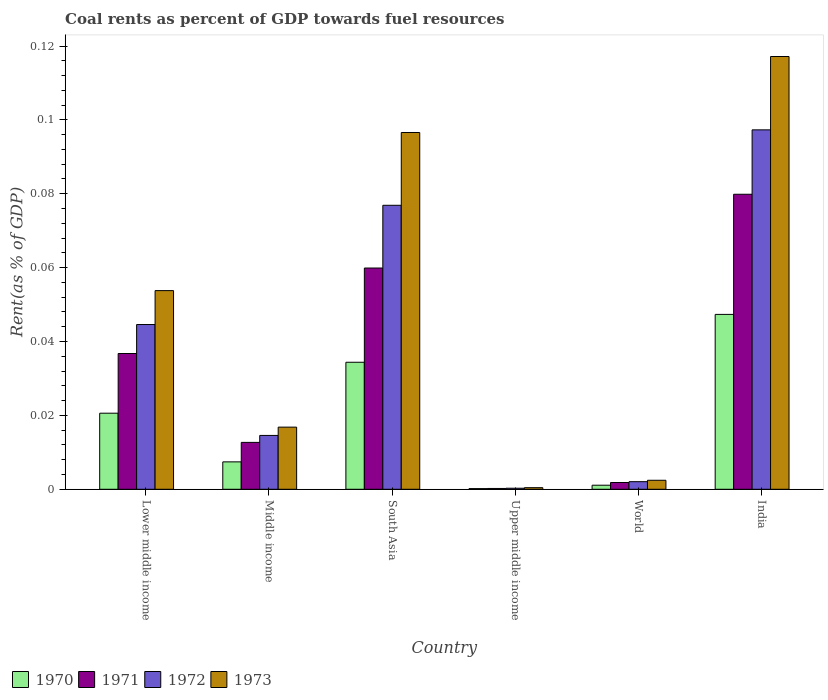Are the number of bars on each tick of the X-axis equal?
Your answer should be very brief. Yes. What is the label of the 6th group of bars from the left?
Offer a very short reply. India. What is the coal rent in 1973 in Upper middle income?
Your response must be concise. 0. Across all countries, what is the maximum coal rent in 1971?
Your answer should be very brief. 0.08. Across all countries, what is the minimum coal rent in 1970?
Offer a terse response. 0. In which country was the coal rent in 1970 minimum?
Provide a succinct answer. Upper middle income. What is the total coal rent in 1971 in the graph?
Offer a very short reply. 0.19. What is the difference between the coal rent in 1973 in Middle income and that in World?
Make the answer very short. 0.01. What is the difference between the coal rent in 1971 in Lower middle income and the coal rent in 1973 in India?
Offer a very short reply. -0.08. What is the average coal rent in 1970 per country?
Provide a succinct answer. 0.02. What is the difference between the coal rent of/in 1971 and coal rent of/in 1972 in Upper middle income?
Your answer should be very brief. -6.559434765832401e-5. What is the ratio of the coal rent in 1970 in Upper middle income to that in World?
Offer a very short reply. 0.17. What is the difference between the highest and the second highest coal rent in 1971?
Your answer should be very brief. 0.04. What is the difference between the highest and the lowest coal rent in 1973?
Keep it short and to the point. 0.12. In how many countries, is the coal rent in 1973 greater than the average coal rent in 1973 taken over all countries?
Offer a terse response. 3. Is the sum of the coal rent in 1971 in Middle income and World greater than the maximum coal rent in 1970 across all countries?
Offer a very short reply. No. What does the 4th bar from the left in Upper middle income represents?
Make the answer very short. 1973. How many bars are there?
Keep it short and to the point. 24. What is the difference between two consecutive major ticks on the Y-axis?
Give a very brief answer. 0.02. Does the graph contain grids?
Give a very brief answer. No. Where does the legend appear in the graph?
Make the answer very short. Bottom left. How many legend labels are there?
Your answer should be compact. 4. What is the title of the graph?
Offer a terse response. Coal rents as percent of GDP towards fuel resources. What is the label or title of the X-axis?
Your response must be concise. Country. What is the label or title of the Y-axis?
Keep it short and to the point. Rent(as % of GDP). What is the Rent(as % of GDP) in 1970 in Lower middle income?
Make the answer very short. 0.02. What is the Rent(as % of GDP) of 1971 in Lower middle income?
Make the answer very short. 0.04. What is the Rent(as % of GDP) of 1972 in Lower middle income?
Offer a very short reply. 0.04. What is the Rent(as % of GDP) of 1973 in Lower middle income?
Provide a short and direct response. 0.05. What is the Rent(as % of GDP) in 1970 in Middle income?
Provide a succinct answer. 0.01. What is the Rent(as % of GDP) of 1971 in Middle income?
Your answer should be compact. 0.01. What is the Rent(as % of GDP) of 1972 in Middle income?
Offer a very short reply. 0.01. What is the Rent(as % of GDP) of 1973 in Middle income?
Keep it short and to the point. 0.02. What is the Rent(as % of GDP) of 1970 in South Asia?
Provide a succinct answer. 0.03. What is the Rent(as % of GDP) in 1971 in South Asia?
Offer a very short reply. 0.06. What is the Rent(as % of GDP) of 1972 in South Asia?
Keep it short and to the point. 0.08. What is the Rent(as % of GDP) of 1973 in South Asia?
Your response must be concise. 0.1. What is the Rent(as % of GDP) in 1970 in Upper middle income?
Your response must be concise. 0. What is the Rent(as % of GDP) of 1971 in Upper middle income?
Give a very brief answer. 0. What is the Rent(as % of GDP) of 1972 in Upper middle income?
Give a very brief answer. 0. What is the Rent(as % of GDP) in 1973 in Upper middle income?
Your response must be concise. 0. What is the Rent(as % of GDP) of 1970 in World?
Offer a very short reply. 0. What is the Rent(as % of GDP) in 1971 in World?
Offer a terse response. 0. What is the Rent(as % of GDP) in 1972 in World?
Offer a terse response. 0. What is the Rent(as % of GDP) in 1973 in World?
Provide a short and direct response. 0. What is the Rent(as % of GDP) of 1970 in India?
Keep it short and to the point. 0.05. What is the Rent(as % of GDP) of 1971 in India?
Offer a terse response. 0.08. What is the Rent(as % of GDP) of 1972 in India?
Offer a very short reply. 0.1. What is the Rent(as % of GDP) of 1973 in India?
Keep it short and to the point. 0.12. Across all countries, what is the maximum Rent(as % of GDP) of 1970?
Your answer should be compact. 0.05. Across all countries, what is the maximum Rent(as % of GDP) in 1971?
Offer a very short reply. 0.08. Across all countries, what is the maximum Rent(as % of GDP) in 1972?
Provide a short and direct response. 0.1. Across all countries, what is the maximum Rent(as % of GDP) in 1973?
Make the answer very short. 0.12. Across all countries, what is the minimum Rent(as % of GDP) of 1970?
Your response must be concise. 0. Across all countries, what is the minimum Rent(as % of GDP) of 1971?
Your answer should be very brief. 0. Across all countries, what is the minimum Rent(as % of GDP) in 1972?
Your answer should be compact. 0. Across all countries, what is the minimum Rent(as % of GDP) of 1973?
Offer a very short reply. 0. What is the total Rent(as % of GDP) of 1970 in the graph?
Ensure brevity in your answer.  0.11. What is the total Rent(as % of GDP) of 1971 in the graph?
Provide a succinct answer. 0.19. What is the total Rent(as % of GDP) in 1972 in the graph?
Ensure brevity in your answer.  0.24. What is the total Rent(as % of GDP) of 1973 in the graph?
Offer a very short reply. 0.29. What is the difference between the Rent(as % of GDP) in 1970 in Lower middle income and that in Middle income?
Your answer should be very brief. 0.01. What is the difference between the Rent(as % of GDP) of 1971 in Lower middle income and that in Middle income?
Your answer should be compact. 0.02. What is the difference between the Rent(as % of GDP) of 1973 in Lower middle income and that in Middle income?
Offer a very short reply. 0.04. What is the difference between the Rent(as % of GDP) in 1970 in Lower middle income and that in South Asia?
Offer a very short reply. -0.01. What is the difference between the Rent(as % of GDP) of 1971 in Lower middle income and that in South Asia?
Your answer should be very brief. -0.02. What is the difference between the Rent(as % of GDP) in 1972 in Lower middle income and that in South Asia?
Your answer should be compact. -0.03. What is the difference between the Rent(as % of GDP) of 1973 in Lower middle income and that in South Asia?
Provide a succinct answer. -0.04. What is the difference between the Rent(as % of GDP) of 1970 in Lower middle income and that in Upper middle income?
Make the answer very short. 0.02. What is the difference between the Rent(as % of GDP) in 1971 in Lower middle income and that in Upper middle income?
Make the answer very short. 0.04. What is the difference between the Rent(as % of GDP) in 1972 in Lower middle income and that in Upper middle income?
Keep it short and to the point. 0.04. What is the difference between the Rent(as % of GDP) of 1973 in Lower middle income and that in Upper middle income?
Make the answer very short. 0.05. What is the difference between the Rent(as % of GDP) in 1970 in Lower middle income and that in World?
Make the answer very short. 0.02. What is the difference between the Rent(as % of GDP) in 1971 in Lower middle income and that in World?
Keep it short and to the point. 0.03. What is the difference between the Rent(as % of GDP) in 1972 in Lower middle income and that in World?
Provide a succinct answer. 0.04. What is the difference between the Rent(as % of GDP) of 1973 in Lower middle income and that in World?
Your response must be concise. 0.05. What is the difference between the Rent(as % of GDP) in 1970 in Lower middle income and that in India?
Offer a terse response. -0.03. What is the difference between the Rent(as % of GDP) in 1971 in Lower middle income and that in India?
Give a very brief answer. -0.04. What is the difference between the Rent(as % of GDP) in 1972 in Lower middle income and that in India?
Give a very brief answer. -0.05. What is the difference between the Rent(as % of GDP) of 1973 in Lower middle income and that in India?
Offer a terse response. -0.06. What is the difference between the Rent(as % of GDP) in 1970 in Middle income and that in South Asia?
Provide a short and direct response. -0.03. What is the difference between the Rent(as % of GDP) of 1971 in Middle income and that in South Asia?
Offer a very short reply. -0.05. What is the difference between the Rent(as % of GDP) of 1972 in Middle income and that in South Asia?
Give a very brief answer. -0.06. What is the difference between the Rent(as % of GDP) of 1973 in Middle income and that in South Asia?
Provide a short and direct response. -0.08. What is the difference between the Rent(as % of GDP) of 1970 in Middle income and that in Upper middle income?
Your answer should be compact. 0.01. What is the difference between the Rent(as % of GDP) of 1971 in Middle income and that in Upper middle income?
Ensure brevity in your answer.  0.01. What is the difference between the Rent(as % of GDP) of 1972 in Middle income and that in Upper middle income?
Provide a short and direct response. 0.01. What is the difference between the Rent(as % of GDP) of 1973 in Middle income and that in Upper middle income?
Keep it short and to the point. 0.02. What is the difference between the Rent(as % of GDP) in 1970 in Middle income and that in World?
Provide a succinct answer. 0.01. What is the difference between the Rent(as % of GDP) in 1971 in Middle income and that in World?
Your answer should be compact. 0.01. What is the difference between the Rent(as % of GDP) in 1972 in Middle income and that in World?
Provide a short and direct response. 0.01. What is the difference between the Rent(as % of GDP) of 1973 in Middle income and that in World?
Your answer should be very brief. 0.01. What is the difference between the Rent(as % of GDP) in 1970 in Middle income and that in India?
Make the answer very short. -0.04. What is the difference between the Rent(as % of GDP) of 1971 in Middle income and that in India?
Ensure brevity in your answer.  -0.07. What is the difference between the Rent(as % of GDP) of 1972 in Middle income and that in India?
Ensure brevity in your answer.  -0.08. What is the difference between the Rent(as % of GDP) of 1973 in Middle income and that in India?
Offer a terse response. -0.1. What is the difference between the Rent(as % of GDP) of 1970 in South Asia and that in Upper middle income?
Your answer should be very brief. 0.03. What is the difference between the Rent(as % of GDP) of 1971 in South Asia and that in Upper middle income?
Make the answer very short. 0.06. What is the difference between the Rent(as % of GDP) in 1972 in South Asia and that in Upper middle income?
Give a very brief answer. 0.08. What is the difference between the Rent(as % of GDP) in 1973 in South Asia and that in Upper middle income?
Ensure brevity in your answer.  0.1. What is the difference between the Rent(as % of GDP) of 1971 in South Asia and that in World?
Your answer should be compact. 0.06. What is the difference between the Rent(as % of GDP) in 1972 in South Asia and that in World?
Ensure brevity in your answer.  0.07. What is the difference between the Rent(as % of GDP) in 1973 in South Asia and that in World?
Your response must be concise. 0.09. What is the difference between the Rent(as % of GDP) in 1970 in South Asia and that in India?
Offer a very short reply. -0.01. What is the difference between the Rent(as % of GDP) of 1971 in South Asia and that in India?
Provide a succinct answer. -0.02. What is the difference between the Rent(as % of GDP) of 1972 in South Asia and that in India?
Ensure brevity in your answer.  -0.02. What is the difference between the Rent(as % of GDP) in 1973 in South Asia and that in India?
Your response must be concise. -0.02. What is the difference between the Rent(as % of GDP) of 1970 in Upper middle income and that in World?
Ensure brevity in your answer.  -0. What is the difference between the Rent(as % of GDP) of 1971 in Upper middle income and that in World?
Your answer should be compact. -0. What is the difference between the Rent(as % of GDP) in 1972 in Upper middle income and that in World?
Provide a short and direct response. -0. What is the difference between the Rent(as % of GDP) in 1973 in Upper middle income and that in World?
Your response must be concise. -0. What is the difference between the Rent(as % of GDP) in 1970 in Upper middle income and that in India?
Offer a terse response. -0.05. What is the difference between the Rent(as % of GDP) in 1971 in Upper middle income and that in India?
Provide a short and direct response. -0.08. What is the difference between the Rent(as % of GDP) in 1972 in Upper middle income and that in India?
Provide a succinct answer. -0.1. What is the difference between the Rent(as % of GDP) of 1973 in Upper middle income and that in India?
Offer a terse response. -0.12. What is the difference between the Rent(as % of GDP) of 1970 in World and that in India?
Make the answer very short. -0.05. What is the difference between the Rent(as % of GDP) of 1971 in World and that in India?
Offer a terse response. -0.08. What is the difference between the Rent(as % of GDP) of 1972 in World and that in India?
Give a very brief answer. -0.1. What is the difference between the Rent(as % of GDP) in 1973 in World and that in India?
Your response must be concise. -0.11. What is the difference between the Rent(as % of GDP) of 1970 in Lower middle income and the Rent(as % of GDP) of 1971 in Middle income?
Offer a terse response. 0.01. What is the difference between the Rent(as % of GDP) of 1970 in Lower middle income and the Rent(as % of GDP) of 1972 in Middle income?
Provide a succinct answer. 0.01. What is the difference between the Rent(as % of GDP) of 1970 in Lower middle income and the Rent(as % of GDP) of 1973 in Middle income?
Offer a terse response. 0. What is the difference between the Rent(as % of GDP) in 1971 in Lower middle income and the Rent(as % of GDP) in 1972 in Middle income?
Make the answer very short. 0.02. What is the difference between the Rent(as % of GDP) in 1971 in Lower middle income and the Rent(as % of GDP) in 1973 in Middle income?
Make the answer very short. 0.02. What is the difference between the Rent(as % of GDP) in 1972 in Lower middle income and the Rent(as % of GDP) in 1973 in Middle income?
Offer a terse response. 0.03. What is the difference between the Rent(as % of GDP) of 1970 in Lower middle income and the Rent(as % of GDP) of 1971 in South Asia?
Your answer should be compact. -0.04. What is the difference between the Rent(as % of GDP) in 1970 in Lower middle income and the Rent(as % of GDP) in 1972 in South Asia?
Give a very brief answer. -0.06. What is the difference between the Rent(as % of GDP) in 1970 in Lower middle income and the Rent(as % of GDP) in 1973 in South Asia?
Your answer should be compact. -0.08. What is the difference between the Rent(as % of GDP) of 1971 in Lower middle income and the Rent(as % of GDP) of 1972 in South Asia?
Offer a terse response. -0.04. What is the difference between the Rent(as % of GDP) in 1971 in Lower middle income and the Rent(as % of GDP) in 1973 in South Asia?
Your answer should be very brief. -0.06. What is the difference between the Rent(as % of GDP) of 1972 in Lower middle income and the Rent(as % of GDP) of 1973 in South Asia?
Offer a very short reply. -0.05. What is the difference between the Rent(as % of GDP) of 1970 in Lower middle income and the Rent(as % of GDP) of 1971 in Upper middle income?
Make the answer very short. 0.02. What is the difference between the Rent(as % of GDP) in 1970 in Lower middle income and the Rent(as % of GDP) in 1972 in Upper middle income?
Give a very brief answer. 0.02. What is the difference between the Rent(as % of GDP) in 1970 in Lower middle income and the Rent(as % of GDP) in 1973 in Upper middle income?
Provide a succinct answer. 0.02. What is the difference between the Rent(as % of GDP) of 1971 in Lower middle income and the Rent(as % of GDP) of 1972 in Upper middle income?
Your answer should be very brief. 0.04. What is the difference between the Rent(as % of GDP) in 1971 in Lower middle income and the Rent(as % of GDP) in 1973 in Upper middle income?
Your response must be concise. 0.04. What is the difference between the Rent(as % of GDP) in 1972 in Lower middle income and the Rent(as % of GDP) in 1973 in Upper middle income?
Provide a succinct answer. 0.04. What is the difference between the Rent(as % of GDP) in 1970 in Lower middle income and the Rent(as % of GDP) in 1971 in World?
Provide a succinct answer. 0.02. What is the difference between the Rent(as % of GDP) of 1970 in Lower middle income and the Rent(as % of GDP) of 1972 in World?
Keep it short and to the point. 0.02. What is the difference between the Rent(as % of GDP) in 1970 in Lower middle income and the Rent(as % of GDP) in 1973 in World?
Your answer should be compact. 0.02. What is the difference between the Rent(as % of GDP) of 1971 in Lower middle income and the Rent(as % of GDP) of 1972 in World?
Ensure brevity in your answer.  0.03. What is the difference between the Rent(as % of GDP) of 1971 in Lower middle income and the Rent(as % of GDP) of 1973 in World?
Make the answer very short. 0.03. What is the difference between the Rent(as % of GDP) of 1972 in Lower middle income and the Rent(as % of GDP) of 1973 in World?
Provide a short and direct response. 0.04. What is the difference between the Rent(as % of GDP) in 1970 in Lower middle income and the Rent(as % of GDP) in 1971 in India?
Give a very brief answer. -0.06. What is the difference between the Rent(as % of GDP) in 1970 in Lower middle income and the Rent(as % of GDP) in 1972 in India?
Give a very brief answer. -0.08. What is the difference between the Rent(as % of GDP) of 1970 in Lower middle income and the Rent(as % of GDP) of 1973 in India?
Your answer should be compact. -0.1. What is the difference between the Rent(as % of GDP) in 1971 in Lower middle income and the Rent(as % of GDP) in 1972 in India?
Ensure brevity in your answer.  -0.06. What is the difference between the Rent(as % of GDP) in 1971 in Lower middle income and the Rent(as % of GDP) in 1973 in India?
Make the answer very short. -0.08. What is the difference between the Rent(as % of GDP) in 1972 in Lower middle income and the Rent(as % of GDP) in 1973 in India?
Your answer should be very brief. -0.07. What is the difference between the Rent(as % of GDP) in 1970 in Middle income and the Rent(as % of GDP) in 1971 in South Asia?
Provide a short and direct response. -0.05. What is the difference between the Rent(as % of GDP) in 1970 in Middle income and the Rent(as % of GDP) in 1972 in South Asia?
Your answer should be compact. -0.07. What is the difference between the Rent(as % of GDP) of 1970 in Middle income and the Rent(as % of GDP) of 1973 in South Asia?
Provide a succinct answer. -0.09. What is the difference between the Rent(as % of GDP) of 1971 in Middle income and the Rent(as % of GDP) of 1972 in South Asia?
Your answer should be very brief. -0.06. What is the difference between the Rent(as % of GDP) of 1971 in Middle income and the Rent(as % of GDP) of 1973 in South Asia?
Your answer should be very brief. -0.08. What is the difference between the Rent(as % of GDP) in 1972 in Middle income and the Rent(as % of GDP) in 1973 in South Asia?
Provide a short and direct response. -0.08. What is the difference between the Rent(as % of GDP) of 1970 in Middle income and the Rent(as % of GDP) of 1971 in Upper middle income?
Keep it short and to the point. 0.01. What is the difference between the Rent(as % of GDP) in 1970 in Middle income and the Rent(as % of GDP) in 1972 in Upper middle income?
Offer a terse response. 0.01. What is the difference between the Rent(as % of GDP) of 1970 in Middle income and the Rent(as % of GDP) of 1973 in Upper middle income?
Ensure brevity in your answer.  0.01. What is the difference between the Rent(as % of GDP) in 1971 in Middle income and the Rent(as % of GDP) in 1972 in Upper middle income?
Provide a short and direct response. 0.01. What is the difference between the Rent(as % of GDP) in 1971 in Middle income and the Rent(as % of GDP) in 1973 in Upper middle income?
Ensure brevity in your answer.  0.01. What is the difference between the Rent(as % of GDP) of 1972 in Middle income and the Rent(as % of GDP) of 1973 in Upper middle income?
Ensure brevity in your answer.  0.01. What is the difference between the Rent(as % of GDP) of 1970 in Middle income and the Rent(as % of GDP) of 1971 in World?
Your response must be concise. 0.01. What is the difference between the Rent(as % of GDP) of 1970 in Middle income and the Rent(as % of GDP) of 1972 in World?
Your answer should be very brief. 0.01. What is the difference between the Rent(as % of GDP) of 1970 in Middle income and the Rent(as % of GDP) of 1973 in World?
Offer a terse response. 0.01. What is the difference between the Rent(as % of GDP) of 1971 in Middle income and the Rent(as % of GDP) of 1972 in World?
Offer a very short reply. 0.01. What is the difference between the Rent(as % of GDP) in 1971 in Middle income and the Rent(as % of GDP) in 1973 in World?
Give a very brief answer. 0.01. What is the difference between the Rent(as % of GDP) of 1972 in Middle income and the Rent(as % of GDP) of 1973 in World?
Make the answer very short. 0.01. What is the difference between the Rent(as % of GDP) of 1970 in Middle income and the Rent(as % of GDP) of 1971 in India?
Your answer should be very brief. -0.07. What is the difference between the Rent(as % of GDP) in 1970 in Middle income and the Rent(as % of GDP) in 1972 in India?
Ensure brevity in your answer.  -0.09. What is the difference between the Rent(as % of GDP) of 1970 in Middle income and the Rent(as % of GDP) of 1973 in India?
Ensure brevity in your answer.  -0.11. What is the difference between the Rent(as % of GDP) of 1971 in Middle income and the Rent(as % of GDP) of 1972 in India?
Ensure brevity in your answer.  -0.08. What is the difference between the Rent(as % of GDP) of 1971 in Middle income and the Rent(as % of GDP) of 1973 in India?
Your answer should be very brief. -0.1. What is the difference between the Rent(as % of GDP) of 1972 in Middle income and the Rent(as % of GDP) of 1973 in India?
Make the answer very short. -0.1. What is the difference between the Rent(as % of GDP) in 1970 in South Asia and the Rent(as % of GDP) in 1971 in Upper middle income?
Keep it short and to the point. 0.03. What is the difference between the Rent(as % of GDP) of 1970 in South Asia and the Rent(as % of GDP) of 1972 in Upper middle income?
Offer a terse response. 0.03. What is the difference between the Rent(as % of GDP) in 1970 in South Asia and the Rent(as % of GDP) in 1973 in Upper middle income?
Offer a very short reply. 0.03. What is the difference between the Rent(as % of GDP) in 1971 in South Asia and the Rent(as % of GDP) in 1972 in Upper middle income?
Ensure brevity in your answer.  0.06. What is the difference between the Rent(as % of GDP) of 1971 in South Asia and the Rent(as % of GDP) of 1973 in Upper middle income?
Your response must be concise. 0.06. What is the difference between the Rent(as % of GDP) of 1972 in South Asia and the Rent(as % of GDP) of 1973 in Upper middle income?
Your answer should be compact. 0.08. What is the difference between the Rent(as % of GDP) in 1970 in South Asia and the Rent(as % of GDP) in 1971 in World?
Provide a succinct answer. 0.03. What is the difference between the Rent(as % of GDP) in 1970 in South Asia and the Rent(as % of GDP) in 1972 in World?
Ensure brevity in your answer.  0.03. What is the difference between the Rent(as % of GDP) of 1970 in South Asia and the Rent(as % of GDP) of 1973 in World?
Give a very brief answer. 0.03. What is the difference between the Rent(as % of GDP) of 1971 in South Asia and the Rent(as % of GDP) of 1972 in World?
Offer a very short reply. 0.06. What is the difference between the Rent(as % of GDP) of 1971 in South Asia and the Rent(as % of GDP) of 1973 in World?
Your answer should be very brief. 0.06. What is the difference between the Rent(as % of GDP) of 1972 in South Asia and the Rent(as % of GDP) of 1973 in World?
Offer a very short reply. 0.07. What is the difference between the Rent(as % of GDP) in 1970 in South Asia and the Rent(as % of GDP) in 1971 in India?
Offer a very short reply. -0.05. What is the difference between the Rent(as % of GDP) of 1970 in South Asia and the Rent(as % of GDP) of 1972 in India?
Your answer should be compact. -0.06. What is the difference between the Rent(as % of GDP) of 1970 in South Asia and the Rent(as % of GDP) of 1973 in India?
Your answer should be compact. -0.08. What is the difference between the Rent(as % of GDP) of 1971 in South Asia and the Rent(as % of GDP) of 1972 in India?
Your answer should be very brief. -0.04. What is the difference between the Rent(as % of GDP) of 1971 in South Asia and the Rent(as % of GDP) of 1973 in India?
Ensure brevity in your answer.  -0.06. What is the difference between the Rent(as % of GDP) in 1972 in South Asia and the Rent(as % of GDP) in 1973 in India?
Make the answer very short. -0.04. What is the difference between the Rent(as % of GDP) in 1970 in Upper middle income and the Rent(as % of GDP) in 1971 in World?
Ensure brevity in your answer.  -0. What is the difference between the Rent(as % of GDP) in 1970 in Upper middle income and the Rent(as % of GDP) in 1972 in World?
Your response must be concise. -0. What is the difference between the Rent(as % of GDP) of 1970 in Upper middle income and the Rent(as % of GDP) of 1973 in World?
Make the answer very short. -0. What is the difference between the Rent(as % of GDP) in 1971 in Upper middle income and the Rent(as % of GDP) in 1972 in World?
Give a very brief answer. -0. What is the difference between the Rent(as % of GDP) in 1971 in Upper middle income and the Rent(as % of GDP) in 1973 in World?
Keep it short and to the point. -0. What is the difference between the Rent(as % of GDP) in 1972 in Upper middle income and the Rent(as % of GDP) in 1973 in World?
Your answer should be very brief. -0. What is the difference between the Rent(as % of GDP) of 1970 in Upper middle income and the Rent(as % of GDP) of 1971 in India?
Ensure brevity in your answer.  -0.08. What is the difference between the Rent(as % of GDP) of 1970 in Upper middle income and the Rent(as % of GDP) of 1972 in India?
Your response must be concise. -0.1. What is the difference between the Rent(as % of GDP) of 1970 in Upper middle income and the Rent(as % of GDP) of 1973 in India?
Keep it short and to the point. -0.12. What is the difference between the Rent(as % of GDP) of 1971 in Upper middle income and the Rent(as % of GDP) of 1972 in India?
Make the answer very short. -0.1. What is the difference between the Rent(as % of GDP) in 1971 in Upper middle income and the Rent(as % of GDP) in 1973 in India?
Ensure brevity in your answer.  -0.12. What is the difference between the Rent(as % of GDP) in 1972 in Upper middle income and the Rent(as % of GDP) in 1973 in India?
Offer a very short reply. -0.12. What is the difference between the Rent(as % of GDP) of 1970 in World and the Rent(as % of GDP) of 1971 in India?
Your response must be concise. -0.08. What is the difference between the Rent(as % of GDP) in 1970 in World and the Rent(as % of GDP) in 1972 in India?
Your response must be concise. -0.1. What is the difference between the Rent(as % of GDP) of 1970 in World and the Rent(as % of GDP) of 1973 in India?
Your answer should be compact. -0.12. What is the difference between the Rent(as % of GDP) in 1971 in World and the Rent(as % of GDP) in 1972 in India?
Ensure brevity in your answer.  -0.1. What is the difference between the Rent(as % of GDP) in 1971 in World and the Rent(as % of GDP) in 1973 in India?
Make the answer very short. -0.12. What is the difference between the Rent(as % of GDP) in 1972 in World and the Rent(as % of GDP) in 1973 in India?
Your answer should be very brief. -0.12. What is the average Rent(as % of GDP) of 1970 per country?
Your answer should be compact. 0.02. What is the average Rent(as % of GDP) of 1971 per country?
Provide a succinct answer. 0.03. What is the average Rent(as % of GDP) of 1972 per country?
Give a very brief answer. 0.04. What is the average Rent(as % of GDP) of 1973 per country?
Your answer should be compact. 0.05. What is the difference between the Rent(as % of GDP) of 1970 and Rent(as % of GDP) of 1971 in Lower middle income?
Offer a very short reply. -0.02. What is the difference between the Rent(as % of GDP) in 1970 and Rent(as % of GDP) in 1972 in Lower middle income?
Keep it short and to the point. -0.02. What is the difference between the Rent(as % of GDP) of 1970 and Rent(as % of GDP) of 1973 in Lower middle income?
Provide a short and direct response. -0.03. What is the difference between the Rent(as % of GDP) of 1971 and Rent(as % of GDP) of 1972 in Lower middle income?
Your answer should be very brief. -0.01. What is the difference between the Rent(as % of GDP) in 1971 and Rent(as % of GDP) in 1973 in Lower middle income?
Your answer should be very brief. -0.02. What is the difference between the Rent(as % of GDP) in 1972 and Rent(as % of GDP) in 1973 in Lower middle income?
Provide a short and direct response. -0.01. What is the difference between the Rent(as % of GDP) in 1970 and Rent(as % of GDP) in 1971 in Middle income?
Keep it short and to the point. -0.01. What is the difference between the Rent(as % of GDP) of 1970 and Rent(as % of GDP) of 1972 in Middle income?
Offer a terse response. -0.01. What is the difference between the Rent(as % of GDP) in 1970 and Rent(as % of GDP) in 1973 in Middle income?
Your answer should be compact. -0.01. What is the difference between the Rent(as % of GDP) in 1971 and Rent(as % of GDP) in 1972 in Middle income?
Ensure brevity in your answer.  -0. What is the difference between the Rent(as % of GDP) of 1971 and Rent(as % of GDP) of 1973 in Middle income?
Provide a short and direct response. -0. What is the difference between the Rent(as % of GDP) of 1972 and Rent(as % of GDP) of 1973 in Middle income?
Your answer should be compact. -0. What is the difference between the Rent(as % of GDP) of 1970 and Rent(as % of GDP) of 1971 in South Asia?
Offer a very short reply. -0.03. What is the difference between the Rent(as % of GDP) in 1970 and Rent(as % of GDP) in 1972 in South Asia?
Keep it short and to the point. -0.04. What is the difference between the Rent(as % of GDP) of 1970 and Rent(as % of GDP) of 1973 in South Asia?
Offer a very short reply. -0.06. What is the difference between the Rent(as % of GDP) in 1971 and Rent(as % of GDP) in 1972 in South Asia?
Offer a very short reply. -0.02. What is the difference between the Rent(as % of GDP) in 1971 and Rent(as % of GDP) in 1973 in South Asia?
Your response must be concise. -0.04. What is the difference between the Rent(as % of GDP) of 1972 and Rent(as % of GDP) of 1973 in South Asia?
Offer a very short reply. -0.02. What is the difference between the Rent(as % of GDP) in 1970 and Rent(as % of GDP) in 1972 in Upper middle income?
Offer a very short reply. -0. What is the difference between the Rent(as % of GDP) in 1970 and Rent(as % of GDP) in 1973 in Upper middle income?
Provide a succinct answer. -0. What is the difference between the Rent(as % of GDP) of 1971 and Rent(as % of GDP) of 1972 in Upper middle income?
Give a very brief answer. -0. What is the difference between the Rent(as % of GDP) in 1971 and Rent(as % of GDP) in 1973 in Upper middle income?
Your answer should be compact. -0. What is the difference between the Rent(as % of GDP) in 1972 and Rent(as % of GDP) in 1973 in Upper middle income?
Your response must be concise. -0. What is the difference between the Rent(as % of GDP) in 1970 and Rent(as % of GDP) in 1971 in World?
Offer a terse response. -0. What is the difference between the Rent(as % of GDP) in 1970 and Rent(as % of GDP) in 1972 in World?
Give a very brief answer. -0. What is the difference between the Rent(as % of GDP) of 1970 and Rent(as % of GDP) of 1973 in World?
Your response must be concise. -0. What is the difference between the Rent(as % of GDP) in 1971 and Rent(as % of GDP) in 1972 in World?
Your answer should be very brief. -0. What is the difference between the Rent(as % of GDP) in 1971 and Rent(as % of GDP) in 1973 in World?
Provide a succinct answer. -0. What is the difference between the Rent(as % of GDP) of 1972 and Rent(as % of GDP) of 1973 in World?
Provide a succinct answer. -0. What is the difference between the Rent(as % of GDP) of 1970 and Rent(as % of GDP) of 1971 in India?
Ensure brevity in your answer.  -0.03. What is the difference between the Rent(as % of GDP) in 1970 and Rent(as % of GDP) in 1973 in India?
Your answer should be very brief. -0.07. What is the difference between the Rent(as % of GDP) in 1971 and Rent(as % of GDP) in 1972 in India?
Provide a succinct answer. -0.02. What is the difference between the Rent(as % of GDP) in 1971 and Rent(as % of GDP) in 1973 in India?
Offer a terse response. -0.04. What is the difference between the Rent(as % of GDP) in 1972 and Rent(as % of GDP) in 1973 in India?
Provide a short and direct response. -0.02. What is the ratio of the Rent(as % of GDP) in 1970 in Lower middle income to that in Middle income?
Keep it short and to the point. 2.78. What is the ratio of the Rent(as % of GDP) in 1971 in Lower middle income to that in Middle income?
Offer a terse response. 2.9. What is the ratio of the Rent(as % of GDP) in 1972 in Lower middle income to that in Middle income?
Keep it short and to the point. 3.06. What is the ratio of the Rent(as % of GDP) of 1973 in Lower middle income to that in Middle income?
Your answer should be very brief. 3.2. What is the ratio of the Rent(as % of GDP) of 1970 in Lower middle income to that in South Asia?
Make the answer very short. 0.6. What is the ratio of the Rent(as % of GDP) of 1971 in Lower middle income to that in South Asia?
Offer a terse response. 0.61. What is the ratio of the Rent(as % of GDP) of 1972 in Lower middle income to that in South Asia?
Provide a succinct answer. 0.58. What is the ratio of the Rent(as % of GDP) in 1973 in Lower middle income to that in South Asia?
Keep it short and to the point. 0.56. What is the ratio of the Rent(as % of GDP) in 1970 in Lower middle income to that in Upper middle income?
Offer a terse response. 112.03. What is the ratio of the Rent(as % of GDP) of 1971 in Lower middle income to that in Upper middle income?
Your answer should be very brief. 167.98. What is the ratio of the Rent(as % of GDP) of 1972 in Lower middle income to that in Upper middle income?
Offer a terse response. 156.82. What is the ratio of the Rent(as % of GDP) in 1973 in Lower middle income to that in Upper middle income?
Provide a succinct answer. 124.82. What is the ratio of the Rent(as % of GDP) in 1970 in Lower middle income to that in World?
Ensure brevity in your answer.  18.71. What is the ratio of the Rent(as % of GDP) in 1971 in Lower middle income to that in World?
Give a very brief answer. 20.06. What is the ratio of the Rent(as % of GDP) in 1972 in Lower middle income to that in World?
Offer a very short reply. 21.7. What is the ratio of the Rent(as % of GDP) in 1973 in Lower middle income to that in World?
Provide a succinct answer. 22.07. What is the ratio of the Rent(as % of GDP) in 1970 in Lower middle income to that in India?
Give a very brief answer. 0.44. What is the ratio of the Rent(as % of GDP) in 1971 in Lower middle income to that in India?
Offer a very short reply. 0.46. What is the ratio of the Rent(as % of GDP) in 1972 in Lower middle income to that in India?
Your answer should be very brief. 0.46. What is the ratio of the Rent(as % of GDP) in 1973 in Lower middle income to that in India?
Your answer should be very brief. 0.46. What is the ratio of the Rent(as % of GDP) in 1970 in Middle income to that in South Asia?
Your response must be concise. 0.22. What is the ratio of the Rent(as % of GDP) in 1971 in Middle income to that in South Asia?
Your response must be concise. 0.21. What is the ratio of the Rent(as % of GDP) of 1972 in Middle income to that in South Asia?
Make the answer very short. 0.19. What is the ratio of the Rent(as % of GDP) in 1973 in Middle income to that in South Asia?
Your answer should be very brief. 0.17. What is the ratio of the Rent(as % of GDP) in 1970 in Middle income to that in Upper middle income?
Ensure brevity in your answer.  40.36. What is the ratio of the Rent(as % of GDP) in 1971 in Middle income to that in Upper middle income?
Provide a short and direct response. 58.01. What is the ratio of the Rent(as % of GDP) of 1972 in Middle income to that in Upper middle income?
Make the answer very short. 51.25. What is the ratio of the Rent(as % of GDP) of 1973 in Middle income to that in Upper middle income?
Provide a succinct answer. 39.04. What is the ratio of the Rent(as % of GDP) of 1970 in Middle income to that in World?
Provide a succinct answer. 6.74. What is the ratio of the Rent(as % of GDP) of 1971 in Middle income to that in World?
Ensure brevity in your answer.  6.93. What is the ratio of the Rent(as % of GDP) of 1972 in Middle income to that in World?
Provide a short and direct response. 7.09. What is the ratio of the Rent(as % of GDP) of 1973 in Middle income to that in World?
Give a very brief answer. 6.91. What is the ratio of the Rent(as % of GDP) of 1970 in Middle income to that in India?
Keep it short and to the point. 0.16. What is the ratio of the Rent(as % of GDP) of 1971 in Middle income to that in India?
Your response must be concise. 0.16. What is the ratio of the Rent(as % of GDP) of 1972 in Middle income to that in India?
Provide a short and direct response. 0.15. What is the ratio of the Rent(as % of GDP) of 1973 in Middle income to that in India?
Ensure brevity in your answer.  0.14. What is the ratio of the Rent(as % of GDP) in 1970 in South Asia to that in Upper middle income?
Provide a succinct answer. 187.05. What is the ratio of the Rent(as % of GDP) of 1971 in South Asia to that in Upper middle income?
Offer a very short reply. 273.74. What is the ratio of the Rent(as % of GDP) of 1972 in South Asia to that in Upper middle income?
Give a very brief answer. 270.32. What is the ratio of the Rent(as % of GDP) in 1973 in South Asia to that in Upper middle income?
Provide a succinct answer. 224.18. What is the ratio of the Rent(as % of GDP) of 1970 in South Asia to that in World?
Provide a succinct answer. 31.24. What is the ratio of the Rent(as % of GDP) of 1971 in South Asia to that in World?
Your response must be concise. 32.69. What is the ratio of the Rent(as % of GDP) in 1972 in South Asia to that in World?
Make the answer very short. 37.41. What is the ratio of the Rent(as % of GDP) of 1973 in South Asia to that in World?
Provide a short and direct response. 39.65. What is the ratio of the Rent(as % of GDP) in 1970 in South Asia to that in India?
Offer a terse response. 0.73. What is the ratio of the Rent(as % of GDP) of 1971 in South Asia to that in India?
Keep it short and to the point. 0.75. What is the ratio of the Rent(as % of GDP) of 1972 in South Asia to that in India?
Ensure brevity in your answer.  0.79. What is the ratio of the Rent(as % of GDP) of 1973 in South Asia to that in India?
Provide a succinct answer. 0.82. What is the ratio of the Rent(as % of GDP) of 1970 in Upper middle income to that in World?
Make the answer very short. 0.17. What is the ratio of the Rent(as % of GDP) in 1971 in Upper middle income to that in World?
Offer a terse response. 0.12. What is the ratio of the Rent(as % of GDP) of 1972 in Upper middle income to that in World?
Your answer should be compact. 0.14. What is the ratio of the Rent(as % of GDP) in 1973 in Upper middle income to that in World?
Offer a very short reply. 0.18. What is the ratio of the Rent(as % of GDP) in 1970 in Upper middle income to that in India?
Give a very brief answer. 0. What is the ratio of the Rent(as % of GDP) in 1971 in Upper middle income to that in India?
Offer a very short reply. 0. What is the ratio of the Rent(as % of GDP) of 1972 in Upper middle income to that in India?
Offer a terse response. 0. What is the ratio of the Rent(as % of GDP) of 1973 in Upper middle income to that in India?
Give a very brief answer. 0. What is the ratio of the Rent(as % of GDP) of 1970 in World to that in India?
Your response must be concise. 0.02. What is the ratio of the Rent(as % of GDP) in 1971 in World to that in India?
Ensure brevity in your answer.  0.02. What is the ratio of the Rent(as % of GDP) of 1972 in World to that in India?
Your answer should be compact. 0.02. What is the ratio of the Rent(as % of GDP) of 1973 in World to that in India?
Provide a succinct answer. 0.02. What is the difference between the highest and the second highest Rent(as % of GDP) of 1970?
Make the answer very short. 0.01. What is the difference between the highest and the second highest Rent(as % of GDP) of 1971?
Your response must be concise. 0.02. What is the difference between the highest and the second highest Rent(as % of GDP) of 1972?
Offer a very short reply. 0.02. What is the difference between the highest and the second highest Rent(as % of GDP) in 1973?
Your response must be concise. 0.02. What is the difference between the highest and the lowest Rent(as % of GDP) in 1970?
Provide a succinct answer. 0.05. What is the difference between the highest and the lowest Rent(as % of GDP) of 1971?
Your answer should be very brief. 0.08. What is the difference between the highest and the lowest Rent(as % of GDP) of 1972?
Ensure brevity in your answer.  0.1. What is the difference between the highest and the lowest Rent(as % of GDP) in 1973?
Offer a terse response. 0.12. 